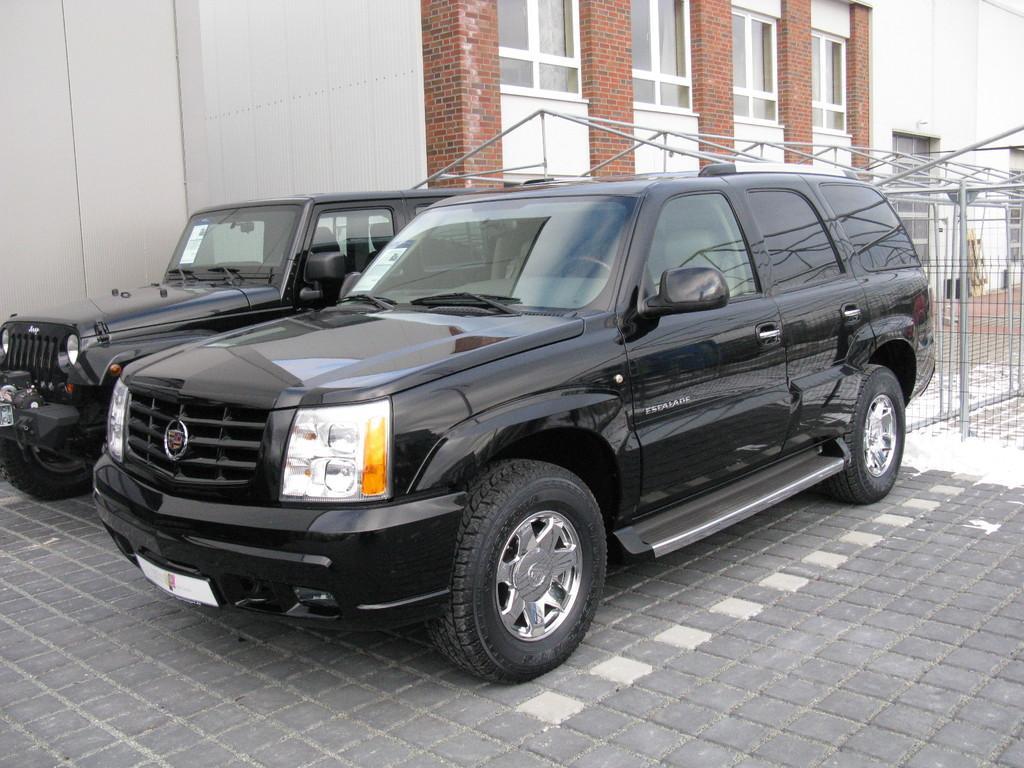Describe this image in one or two sentences. In the foreground of this picture, there are two black cars on the ground. In the background, there is a building and a construction with rods. 